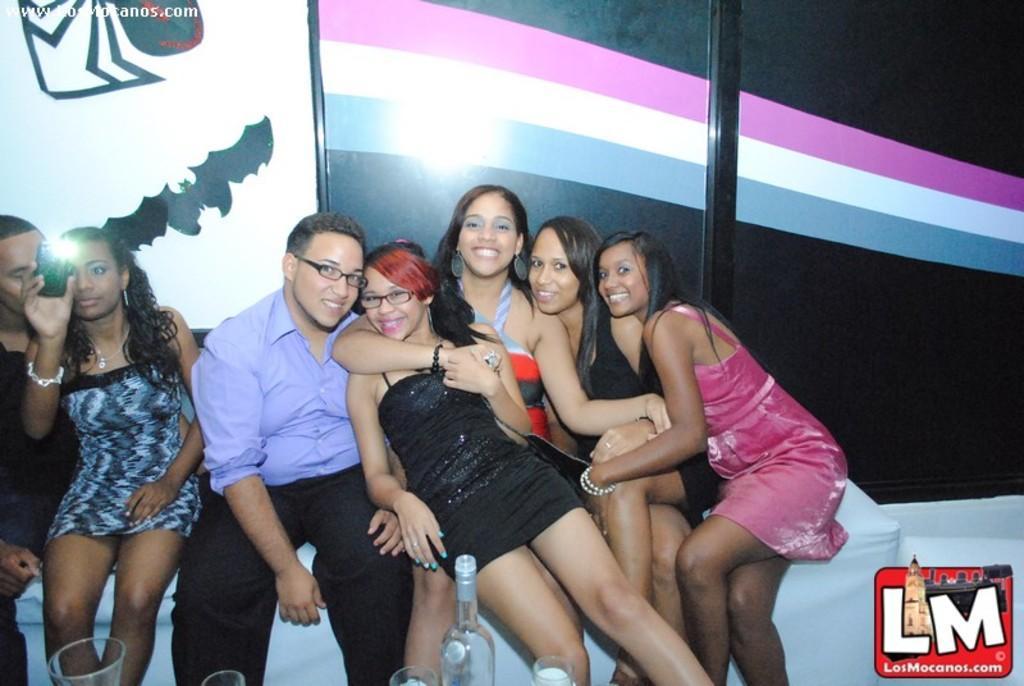Please provide a concise description of this image. In this picture I can see few people seated and a woman holding a mobile and I can see couple of them wore spectacles and I can see a bottle and few glasses and I can see a logo at the bottom right corner of the picture and some text on the top left corner of the picture. 